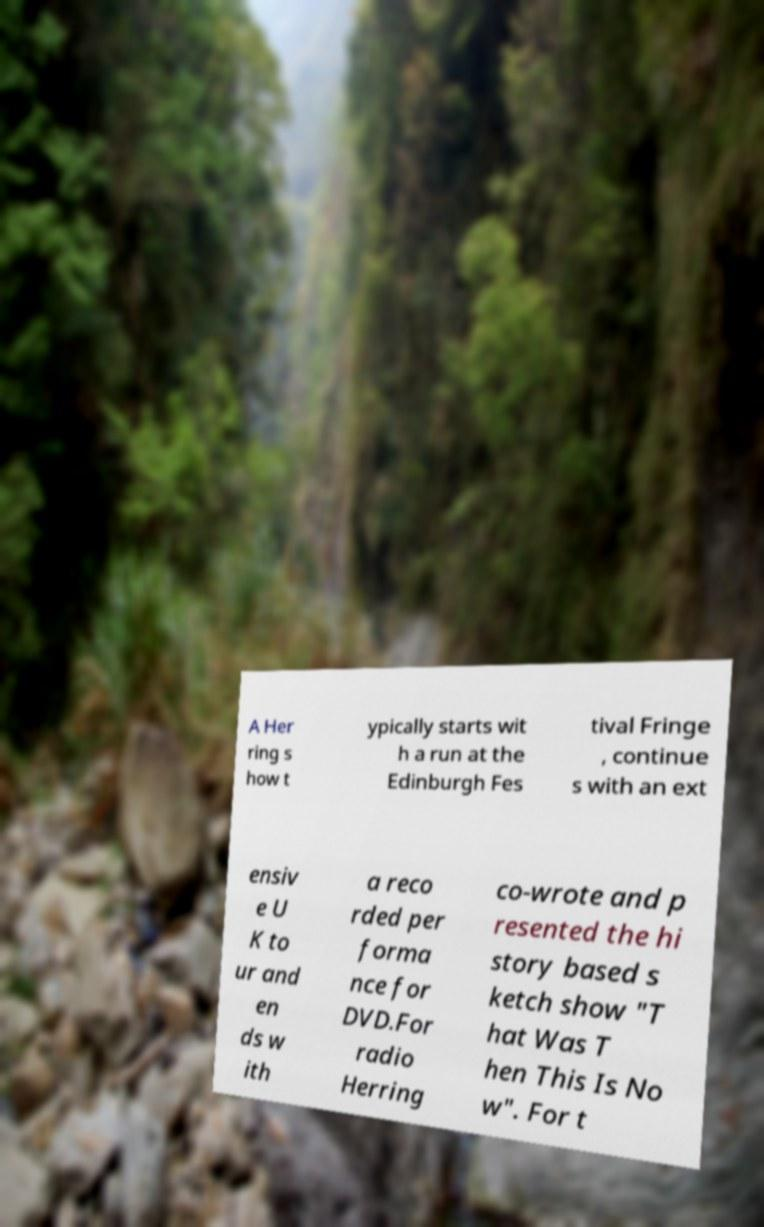Please read and relay the text visible in this image. What does it say? A Her ring s how t ypically starts wit h a run at the Edinburgh Fes tival Fringe , continue s with an ext ensiv e U K to ur and en ds w ith a reco rded per forma nce for DVD.For radio Herring co-wrote and p resented the hi story based s ketch show "T hat Was T hen This Is No w". For t 